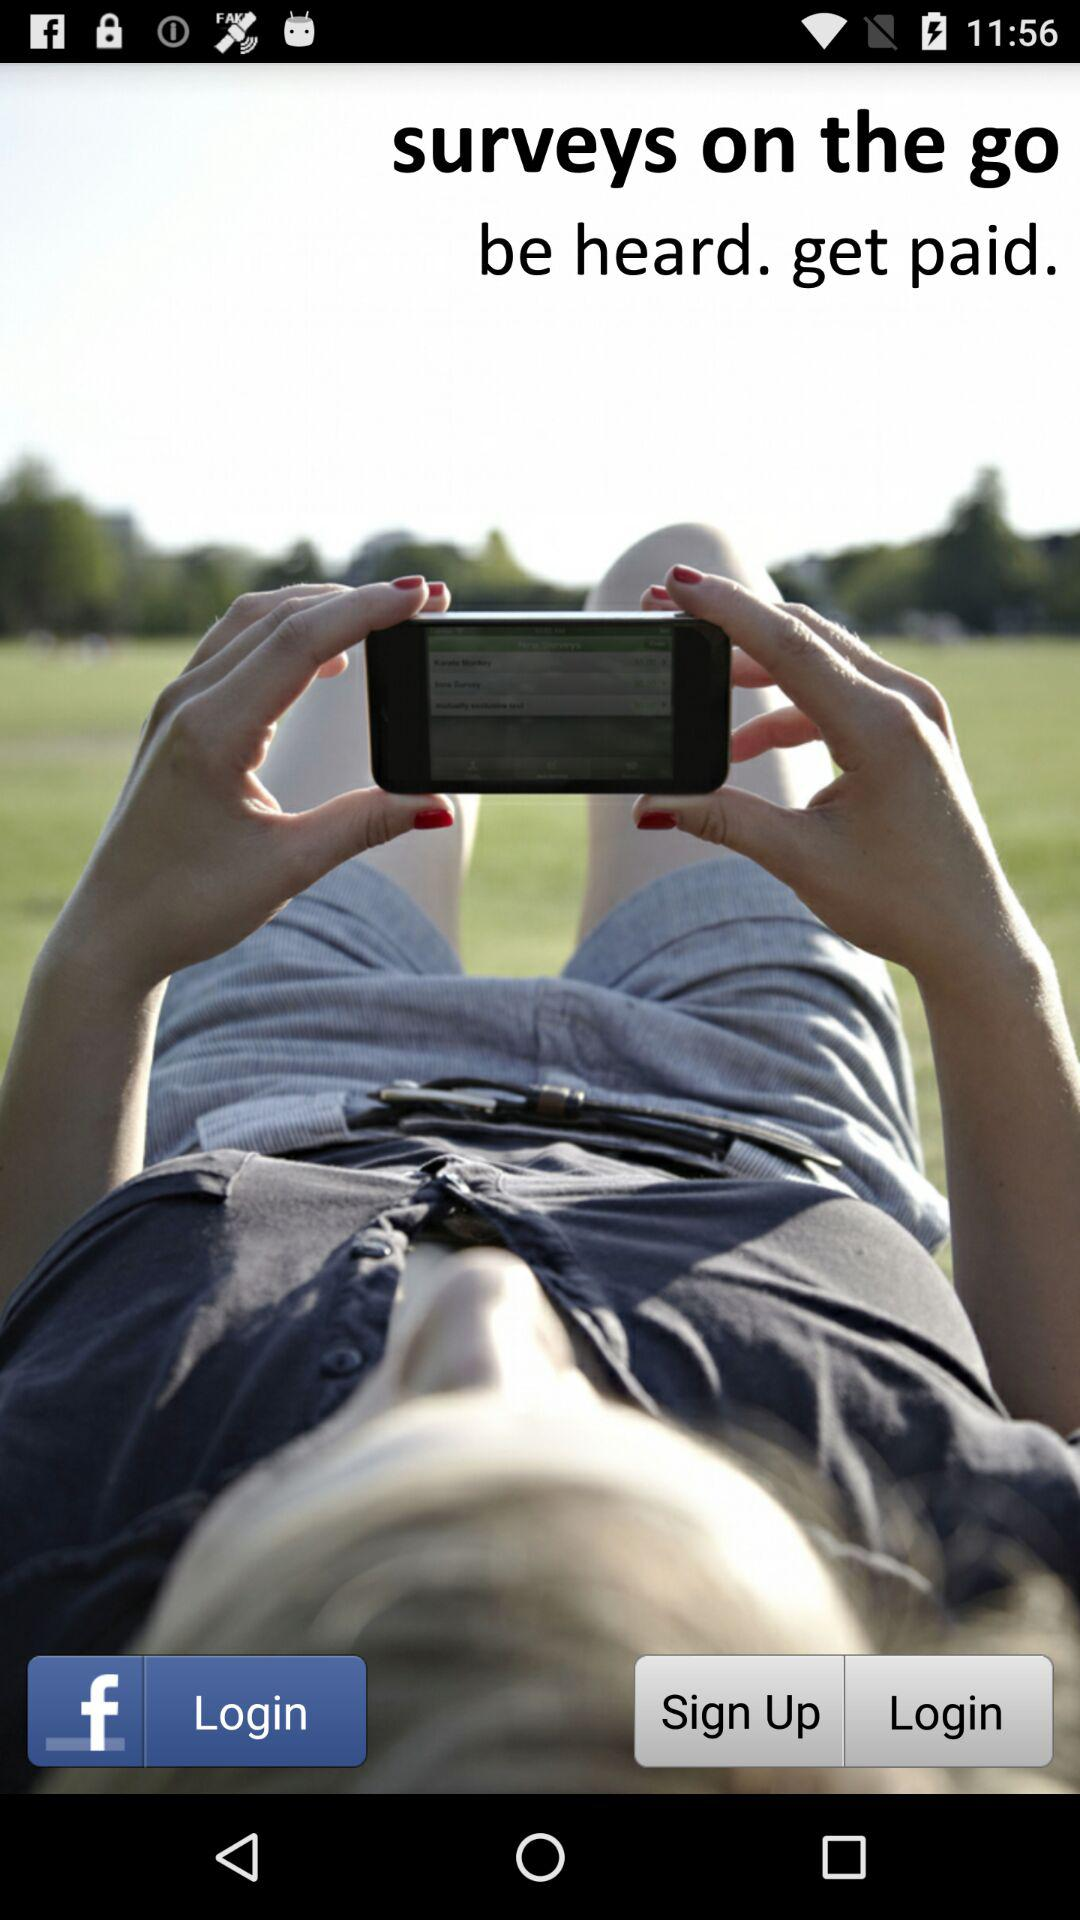What application can we use for login? You can login with Facebook. 